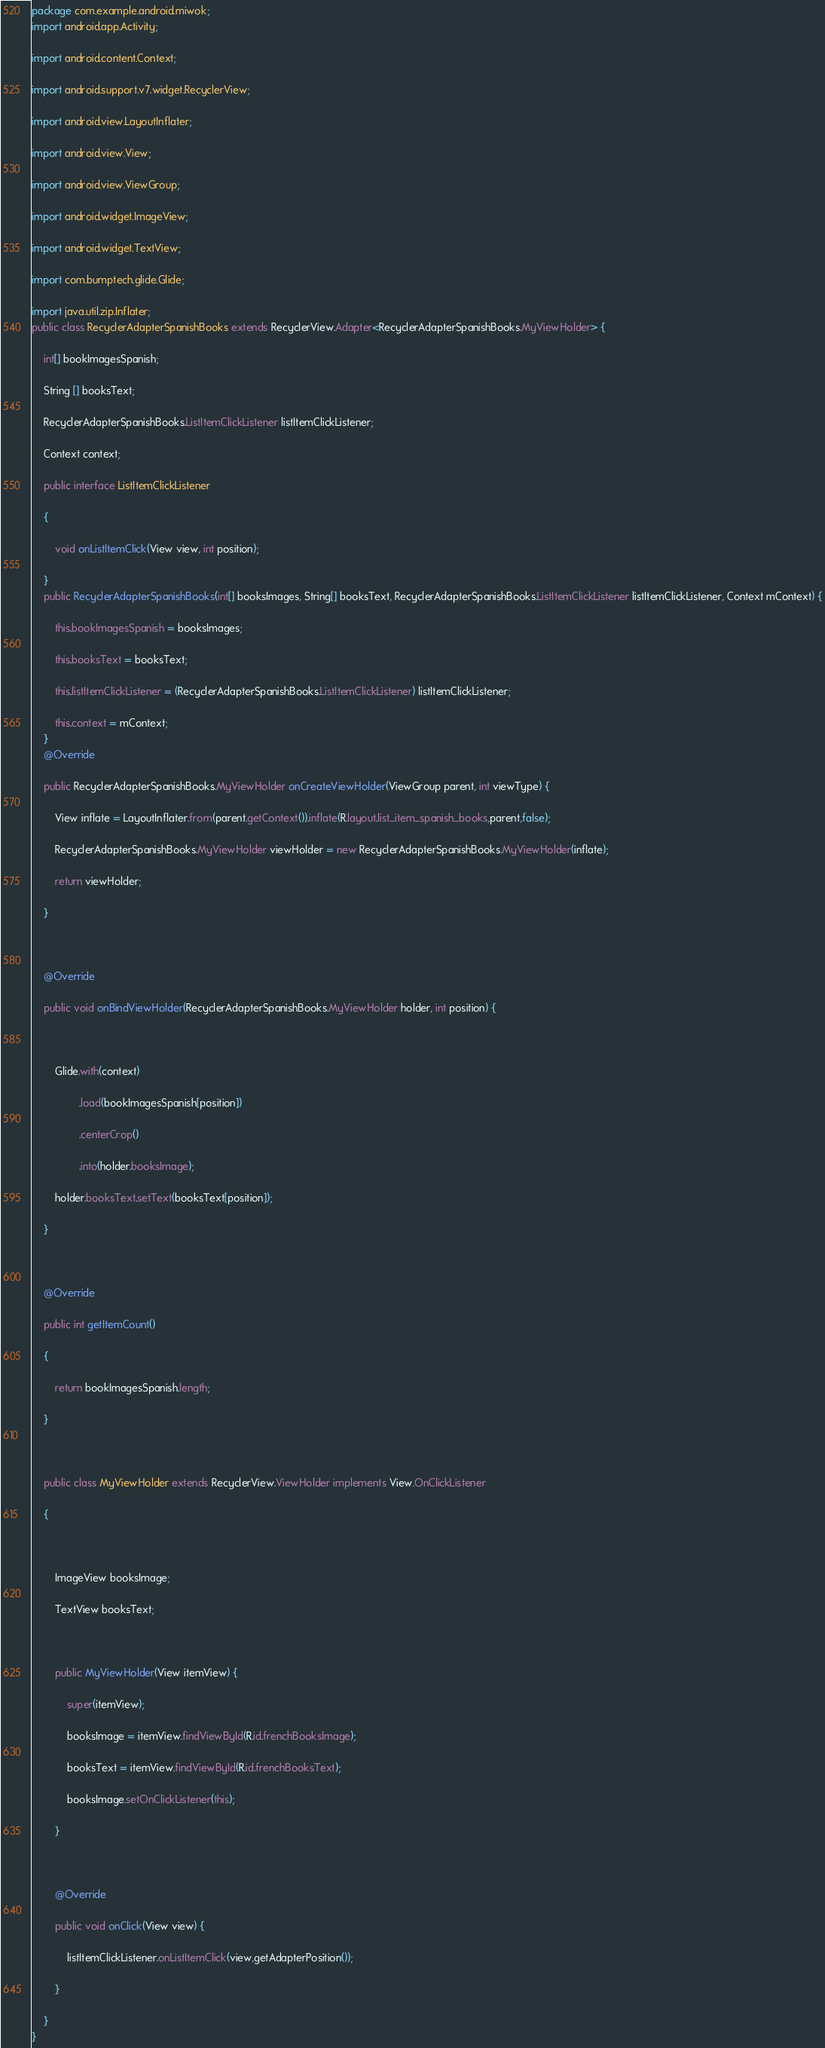Convert code to text. <code><loc_0><loc_0><loc_500><loc_500><_Java_>package com.example.android.miwok;
import android.app.Activity;

import android.content.Context;

import android.support.v7.widget.RecyclerView;

import android.view.LayoutInflater;

import android.view.View;

import android.view.ViewGroup;

import android.widget.ImageView;

import android.widget.TextView;

import com.bumptech.glide.Glide;

import java.util.zip.Inflater;
public class RecyclerAdapterSpanishBooks extends RecyclerView.Adapter<RecyclerAdapterSpanishBooks.MyViewHolder> {

    int[] bookImagesSpanish;

    String [] booksText;

    RecyclerAdapterSpanishBooks.ListItemClickListener listItemClickListener;

    Context context;

    public interface ListItemClickListener

    {

        void onListItemClick(View view, int position);

    }
    public RecyclerAdapterSpanishBooks(int[] booksImages, String[] booksText, RecyclerAdapterSpanishBooks.ListItemClickListener listItemClickListener, Context mContext) {

        this.bookImagesSpanish = booksImages;

        this.booksText = booksText;

        this.listItemClickListener = (RecyclerAdapterSpanishBooks.ListItemClickListener) listItemClickListener;

        this.context = mContext;
    }
    @Override

    public RecyclerAdapterSpanishBooks.MyViewHolder onCreateViewHolder(ViewGroup parent, int viewType) {

        View inflate = LayoutInflater.from(parent.getContext()).inflate(R.layout.list_item_spanish_books,parent,false);

        RecyclerAdapterSpanishBooks.MyViewHolder viewHolder = new RecyclerAdapterSpanishBooks.MyViewHolder(inflate);

        return viewHolder;

    }



    @Override

    public void onBindViewHolder(RecyclerAdapterSpanishBooks.MyViewHolder holder, int position) {



        Glide.with(context)

                .load(bookImagesSpanish[position])

                .centerCrop()

                .into(holder.booksImage);

        holder.booksText.setText(booksText[position]);

    }



    @Override

    public int getItemCount()

    {

        return bookImagesSpanish.length;

    }



    public class MyViewHolder extends RecyclerView.ViewHolder implements View.OnClickListener

    {



        ImageView booksImage;

        TextView booksText;



        public MyViewHolder(View itemView) {

            super(itemView);

            booksImage = itemView.findViewById(R.id.frenchBooksImage);

            booksText = itemView.findViewById(R.id.frenchBooksText);

            booksImage.setOnClickListener(this);

        }



        @Override

        public void onClick(View view) {

            listItemClickListener.onListItemClick(view,getAdapterPosition());

        }

    }
}
</code> 